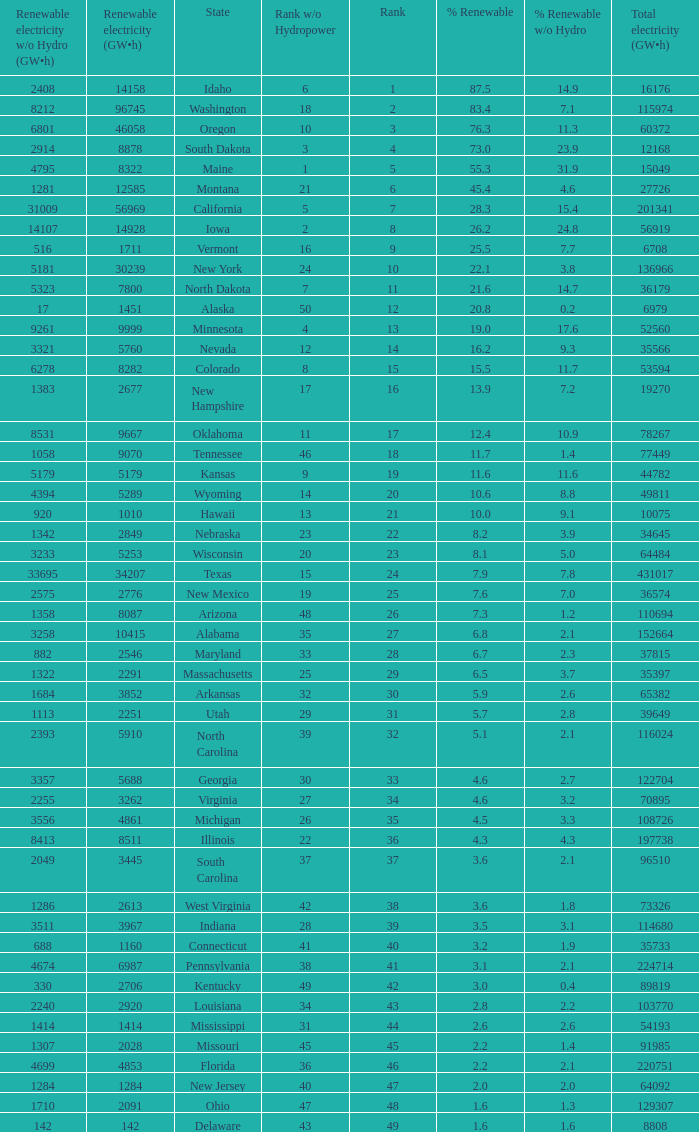Parse the full table. {'header': ['Renewable electricity w/o Hydro (GW•h)', 'Renewable electricity (GW•h)', 'State', 'Rank w/o Hydropower', 'Rank', '% Renewable', '% Renewable w/o Hydro', 'Total electricity (GW•h)'], 'rows': [['2408', '14158', 'Idaho', '6', '1', '87.5', '14.9', '16176'], ['8212', '96745', 'Washington', '18', '2', '83.4', '7.1', '115974'], ['6801', '46058', 'Oregon', '10', '3', '76.3', '11.3', '60372'], ['2914', '8878', 'South Dakota', '3', '4', '73.0', '23.9', '12168'], ['4795', '8322', 'Maine', '1', '5', '55.3', '31.9', '15049'], ['1281', '12585', 'Montana', '21', '6', '45.4', '4.6', '27726'], ['31009', '56969', 'California', '5', '7', '28.3', '15.4', '201341'], ['14107', '14928', 'Iowa', '2', '8', '26.2', '24.8', '56919'], ['516', '1711', 'Vermont', '16', '9', '25.5', '7.7', '6708'], ['5181', '30239', 'New York', '24', '10', '22.1', '3.8', '136966'], ['5323', '7800', 'North Dakota', '7', '11', '21.6', '14.7', '36179'], ['17', '1451', 'Alaska', '50', '12', '20.8', '0.2', '6979'], ['9261', '9999', 'Minnesota', '4', '13', '19.0', '17.6', '52560'], ['3321', '5760', 'Nevada', '12', '14', '16.2', '9.3', '35566'], ['6278', '8282', 'Colorado', '8', '15', '15.5', '11.7', '53594'], ['1383', '2677', 'New Hampshire', '17', '16', '13.9', '7.2', '19270'], ['8531', '9667', 'Oklahoma', '11', '17', '12.4', '10.9', '78267'], ['1058', '9070', 'Tennessee', '46', '18', '11.7', '1.4', '77449'], ['5179', '5179', 'Kansas', '9', '19', '11.6', '11.6', '44782'], ['4394', '5289', 'Wyoming', '14', '20', '10.6', '8.8', '49811'], ['920', '1010', 'Hawaii', '13', '21', '10.0', '9.1', '10075'], ['1342', '2849', 'Nebraska', '23', '22', '8.2', '3.9', '34645'], ['3233', '5253', 'Wisconsin', '20', '23', '8.1', '5.0', '64484'], ['33695', '34207', 'Texas', '15', '24', '7.9', '7.8', '431017'], ['2575', '2776', 'New Mexico', '19', '25', '7.6', '7.0', '36574'], ['1358', '8087', 'Arizona', '48', '26', '7.3', '1.2', '110694'], ['3258', '10415', 'Alabama', '35', '27', '6.8', '2.1', '152664'], ['882', '2546', 'Maryland', '33', '28', '6.7', '2.3', '37815'], ['1322', '2291', 'Massachusetts', '25', '29', '6.5', '3.7', '35397'], ['1684', '3852', 'Arkansas', '32', '30', '5.9', '2.6', '65382'], ['1113', '2251', 'Utah', '29', '31', '5.7', '2.8', '39649'], ['2393', '5910', 'North Carolina', '39', '32', '5.1', '2.1', '116024'], ['3357', '5688', 'Georgia', '30', '33', '4.6', '2.7', '122704'], ['2255', '3262', 'Virginia', '27', '34', '4.6', '3.2', '70895'], ['3556', '4861', 'Michigan', '26', '35', '4.5', '3.3', '108726'], ['8413', '8511', 'Illinois', '22', '36', '4.3', '4.3', '197738'], ['2049', '3445', 'South Carolina', '37', '37', '3.6', '2.1', '96510'], ['1286', '2613', 'West Virginia', '42', '38', '3.6', '1.8', '73326'], ['3511', '3967', 'Indiana', '28', '39', '3.5', '3.1', '114680'], ['688', '1160', 'Connecticut', '41', '40', '3.2', '1.9', '35733'], ['4674', '6987', 'Pennsylvania', '38', '41', '3.1', '2.1', '224714'], ['330', '2706', 'Kentucky', '49', '42', '3.0', '0.4', '89819'], ['2240', '2920', 'Louisiana', '34', '43', '2.8', '2.2', '103770'], ['1414', '1414', 'Mississippi', '31', '44', '2.6', '2.6', '54193'], ['1307', '2028', 'Missouri', '45', '45', '2.2', '1.4', '91985'], ['4699', '4853', 'Florida', '36', '46', '2.2', '2.1', '220751'], ['1284', '1284', 'New Jersey', '40', '47', '2.0', '2.0', '64092'], ['1710', '2091', 'Ohio', '47', '48', '1.6', '1.3', '129307'], ['142', '142', 'Delaware', '43', '49', '1.6', '1.6', '8808']]} What is the maximum renewable energy (gw×h) for the state of Delaware? 142.0. 